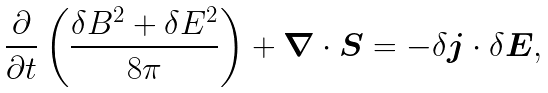Convert formula to latex. <formula><loc_0><loc_0><loc_500><loc_500>\frac { \partial } { \partial t } \left ( \frac { \delta B ^ { 2 } + \delta E ^ { 2 } } { 8 \pi } \right ) + { \boldsymbol \nabla } \cdot { \boldsymbol S } = - { \delta \boldsymbol j } \cdot \delta { \boldsymbol E } ,</formula> 